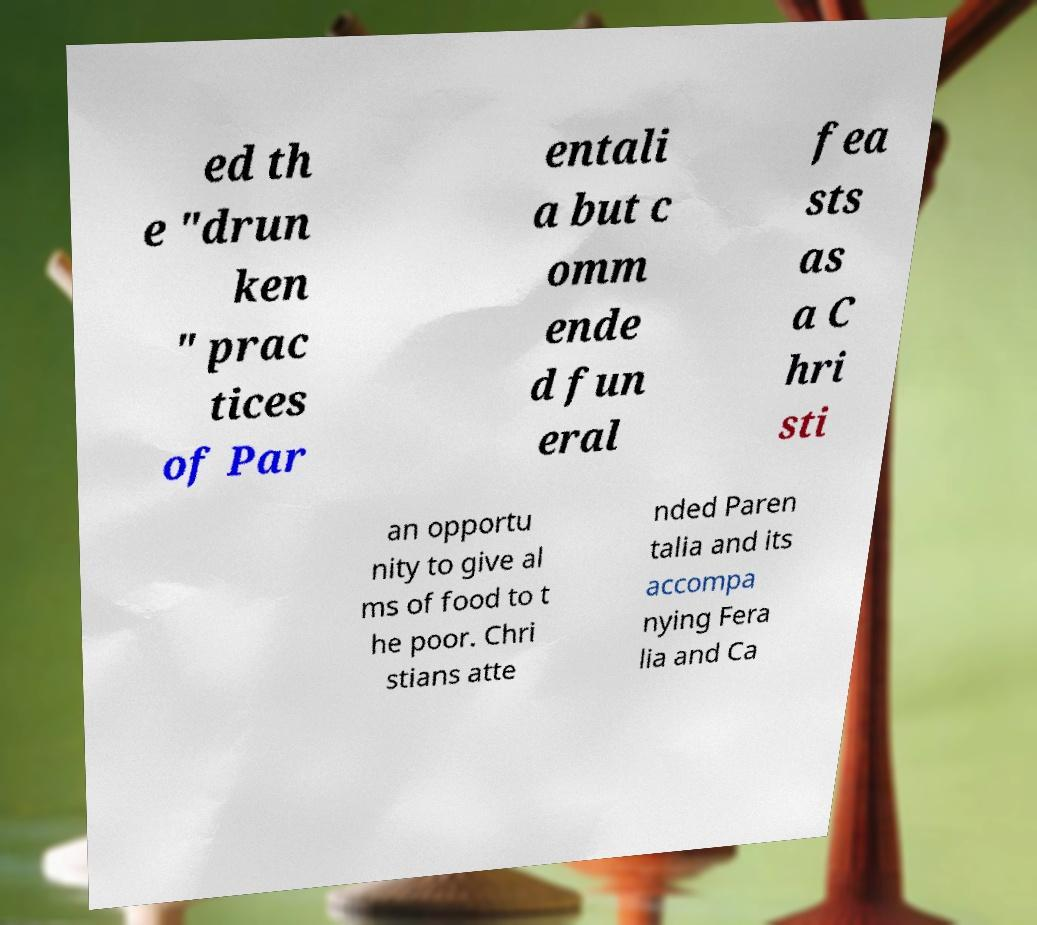Can you read and provide the text displayed in the image?This photo seems to have some interesting text. Can you extract and type it out for me? ed th e "drun ken " prac tices of Par entali a but c omm ende d fun eral fea sts as a C hri sti an opportu nity to give al ms of food to t he poor. Chri stians atte nded Paren talia and its accompa nying Fera lia and Ca 